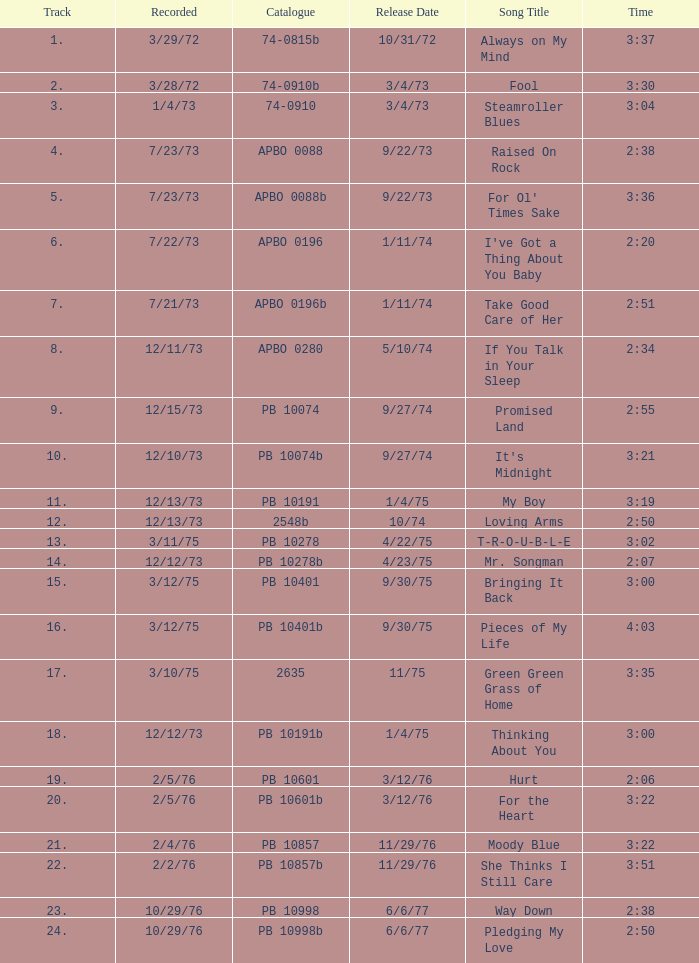I want the sum of tracks for raised on rock 4.0. 